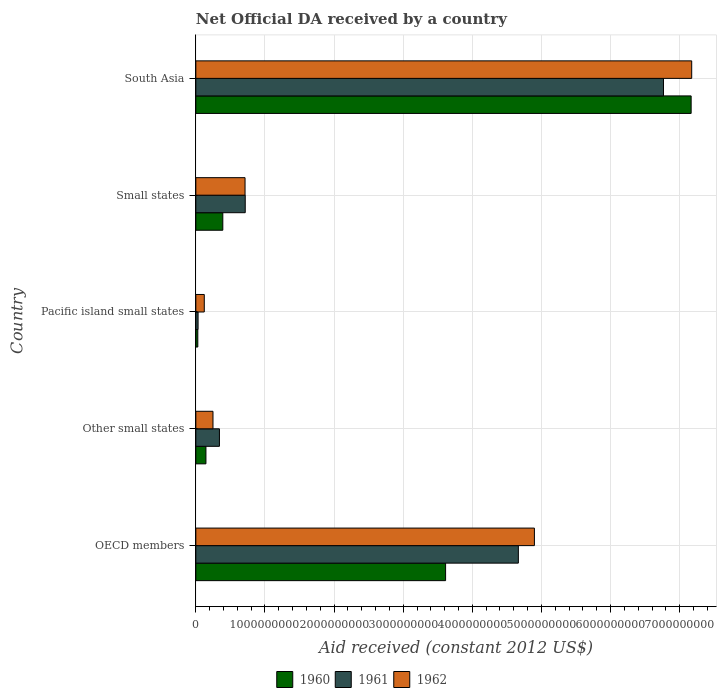How many different coloured bars are there?
Offer a terse response. 3. Are the number of bars per tick equal to the number of legend labels?
Offer a terse response. Yes. Are the number of bars on each tick of the Y-axis equal?
Offer a very short reply. Yes. How many bars are there on the 5th tick from the bottom?
Provide a short and direct response. 3. What is the label of the 5th group of bars from the top?
Make the answer very short. OECD members. In how many cases, is the number of bars for a given country not equal to the number of legend labels?
Offer a very short reply. 0. What is the net official development assistance aid received in 1962 in Pacific island small states?
Your response must be concise. 1.22e+08. Across all countries, what is the maximum net official development assistance aid received in 1961?
Give a very brief answer. 6.76e+09. Across all countries, what is the minimum net official development assistance aid received in 1962?
Provide a succinct answer. 1.22e+08. In which country was the net official development assistance aid received in 1961 minimum?
Offer a very short reply. Pacific island small states. What is the total net official development assistance aid received in 1960 in the graph?
Your answer should be compact. 1.13e+1. What is the difference between the net official development assistance aid received in 1961 in OECD members and that in Pacific island small states?
Ensure brevity in your answer.  4.63e+09. What is the difference between the net official development assistance aid received in 1960 in Other small states and the net official development assistance aid received in 1962 in Small states?
Your answer should be compact. -5.66e+08. What is the average net official development assistance aid received in 1960 per country?
Provide a succinct answer. 2.27e+09. What is the difference between the net official development assistance aid received in 1961 and net official development assistance aid received in 1960 in OECD members?
Make the answer very short. 1.05e+09. In how many countries, is the net official development assistance aid received in 1961 greater than 7200000000 US$?
Your answer should be very brief. 0. What is the ratio of the net official development assistance aid received in 1961 in Pacific island small states to that in South Asia?
Your answer should be compact. 0. Is the net official development assistance aid received in 1961 in Pacific island small states less than that in Small states?
Offer a terse response. Yes. Is the difference between the net official development assistance aid received in 1961 in Pacific island small states and South Asia greater than the difference between the net official development assistance aid received in 1960 in Pacific island small states and South Asia?
Offer a terse response. Yes. What is the difference between the highest and the second highest net official development assistance aid received in 1960?
Give a very brief answer. 3.55e+09. What is the difference between the highest and the lowest net official development assistance aid received in 1960?
Your answer should be very brief. 7.14e+09. In how many countries, is the net official development assistance aid received in 1961 greater than the average net official development assistance aid received in 1961 taken over all countries?
Provide a succinct answer. 2. What does the 2nd bar from the bottom in Other small states represents?
Your response must be concise. 1961. Is it the case that in every country, the sum of the net official development assistance aid received in 1961 and net official development assistance aid received in 1960 is greater than the net official development assistance aid received in 1962?
Provide a succinct answer. No. How many bars are there?
Provide a succinct answer. 15. How many countries are there in the graph?
Make the answer very short. 5. What is the difference between two consecutive major ticks on the X-axis?
Your response must be concise. 1.00e+09. Does the graph contain any zero values?
Keep it short and to the point. No. Where does the legend appear in the graph?
Your answer should be compact. Bottom center. How are the legend labels stacked?
Make the answer very short. Horizontal. What is the title of the graph?
Your answer should be very brief. Net Official DA received by a country. What is the label or title of the X-axis?
Provide a succinct answer. Aid received (constant 2012 US$). What is the label or title of the Y-axis?
Ensure brevity in your answer.  Country. What is the Aid received (constant 2012 US$) of 1960 in OECD members?
Offer a very short reply. 3.61e+09. What is the Aid received (constant 2012 US$) of 1961 in OECD members?
Provide a short and direct response. 4.67e+09. What is the Aid received (constant 2012 US$) of 1962 in OECD members?
Provide a succinct answer. 4.90e+09. What is the Aid received (constant 2012 US$) of 1960 in Other small states?
Your answer should be compact. 1.46e+08. What is the Aid received (constant 2012 US$) in 1961 in Other small states?
Your response must be concise. 3.41e+08. What is the Aid received (constant 2012 US$) in 1962 in Other small states?
Provide a short and direct response. 2.48e+08. What is the Aid received (constant 2012 US$) in 1960 in Pacific island small states?
Your answer should be compact. 2.87e+07. What is the Aid received (constant 2012 US$) of 1961 in Pacific island small states?
Provide a succinct answer. 3.25e+07. What is the Aid received (constant 2012 US$) in 1962 in Pacific island small states?
Your response must be concise. 1.22e+08. What is the Aid received (constant 2012 US$) of 1960 in Small states?
Your answer should be compact. 3.90e+08. What is the Aid received (constant 2012 US$) of 1961 in Small states?
Your response must be concise. 7.15e+08. What is the Aid received (constant 2012 US$) of 1962 in Small states?
Your answer should be compact. 7.12e+08. What is the Aid received (constant 2012 US$) of 1960 in South Asia?
Offer a terse response. 7.17e+09. What is the Aid received (constant 2012 US$) of 1961 in South Asia?
Make the answer very short. 6.76e+09. What is the Aid received (constant 2012 US$) of 1962 in South Asia?
Ensure brevity in your answer.  7.17e+09. Across all countries, what is the maximum Aid received (constant 2012 US$) of 1960?
Provide a succinct answer. 7.17e+09. Across all countries, what is the maximum Aid received (constant 2012 US$) in 1961?
Offer a terse response. 6.76e+09. Across all countries, what is the maximum Aid received (constant 2012 US$) of 1962?
Give a very brief answer. 7.17e+09. Across all countries, what is the minimum Aid received (constant 2012 US$) of 1960?
Offer a very short reply. 2.87e+07. Across all countries, what is the minimum Aid received (constant 2012 US$) in 1961?
Provide a short and direct response. 3.25e+07. Across all countries, what is the minimum Aid received (constant 2012 US$) in 1962?
Your answer should be very brief. 1.22e+08. What is the total Aid received (constant 2012 US$) of 1960 in the graph?
Your answer should be very brief. 1.13e+1. What is the total Aid received (constant 2012 US$) in 1961 in the graph?
Give a very brief answer. 1.25e+1. What is the total Aid received (constant 2012 US$) in 1962 in the graph?
Give a very brief answer. 1.32e+1. What is the difference between the Aid received (constant 2012 US$) in 1960 in OECD members and that in Other small states?
Make the answer very short. 3.47e+09. What is the difference between the Aid received (constant 2012 US$) of 1961 in OECD members and that in Other small states?
Your response must be concise. 4.32e+09. What is the difference between the Aid received (constant 2012 US$) of 1962 in OECD members and that in Other small states?
Your answer should be compact. 4.65e+09. What is the difference between the Aid received (constant 2012 US$) of 1960 in OECD members and that in Pacific island small states?
Make the answer very short. 3.58e+09. What is the difference between the Aid received (constant 2012 US$) in 1961 in OECD members and that in Pacific island small states?
Your answer should be compact. 4.63e+09. What is the difference between the Aid received (constant 2012 US$) of 1962 in OECD members and that in Pacific island small states?
Give a very brief answer. 4.78e+09. What is the difference between the Aid received (constant 2012 US$) of 1960 in OECD members and that in Small states?
Your response must be concise. 3.22e+09. What is the difference between the Aid received (constant 2012 US$) in 1961 in OECD members and that in Small states?
Provide a short and direct response. 3.95e+09. What is the difference between the Aid received (constant 2012 US$) of 1962 in OECD members and that in Small states?
Provide a short and direct response. 4.19e+09. What is the difference between the Aid received (constant 2012 US$) in 1960 in OECD members and that in South Asia?
Provide a short and direct response. -3.55e+09. What is the difference between the Aid received (constant 2012 US$) of 1961 in OECD members and that in South Asia?
Ensure brevity in your answer.  -2.10e+09. What is the difference between the Aid received (constant 2012 US$) of 1962 in OECD members and that in South Asia?
Ensure brevity in your answer.  -2.28e+09. What is the difference between the Aid received (constant 2012 US$) in 1960 in Other small states and that in Pacific island small states?
Provide a succinct answer. 1.17e+08. What is the difference between the Aid received (constant 2012 US$) in 1961 in Other small states and that in Pacific island small states?
Ensure brevity in your answer.  3.09e+08. What is the difference between the Aid received (constant 2012 US$) in 1962 in Other small states and that in Pacific island small states?
Offer a very short reply. 1.26e+08. What is the difference between the Aid received (constant 2012 US$) of 1960 in Other small states and that in Small states?
Provide a succinct answer. -2.44e+08. What is the difference between the Aid received (constant 2012 US$) in 1961 in Other small states and that in Small states?
Offer a terse response. -3.73e+08. What is the difference between the Aid received (constant 2012 US$) in 1962 in Other small states and that in Small states?
Your answer should be very brief. -4.64e+08. What is the difference between the Aid received (constant 2012 US$) of 1960 in Other small states and that in South Asia?
Make the answer very short. -7.02e+09. What is the difference between the Aid received (constant 2012 US$) of 1961 in Other small states and that in South Asia?
Offer a very short reply. -6.42e+09. What is the difference between the Aid received (constant 2012 US$) of 1962 in Other small states and that in South Asia?
Offer a terse response. -6.93e+09. What is the difference between the Aid received (constant 2012 US$) in 1960 in Pacific island small states and that in Small states?
Your answer should be compact. -3.62e+08. What is the difference between the Aid received (constant 2012 US$) of 1961 in Pacific island small states and that in Small states?
Ensure brevity in your answer.  -6.82e+08. What is the difference between the Aid received (constant 2012 US$) in 1962 in Pacific island small states and that in Small states?
Provide a succinct answer. -5.90e+08. What is the difference between the Aid received (constant 2012 US$) in 1960 in Pacific island small states and that in South Asia?
Provide a short and direct response. -7.14e+09. What is the difference between the Aid received (constant 2012 US$) of 1961 in Pacific island small states and that in South Asia?
Give a very brief answer. -6.73e+09. What is the difference between the Aid received (constant 2012 US$) of 1962 in Pacific island small states and that in South Asia?
Your answer should be compact. -7.05e+09. What is the difference between the Aid received (constant 2012 US$) in 1960 in Small states and that in South Asia?
Provide a succinct answer. -6.77e+09. What is the difference between the Aid received (constant 2012 US$) of 1961 in Small states and that in South Asia?
Offer a terse response. -6.05e+09. What is the difference between the Aid received (constant 2012 US$) of 1962 in Small states and that in South Asia?
Your response must be concise. -6.46e+09. What is the difference between the Aid received (constant 2012 US$) in 1960 in OECD members and the Aid received (constant 2012 US$) in 1961 in Other small states?
Ensure brevity in your answer.  3.27e+09. What is the difference between the Aid received (constant 2012 US$) of 1960 in OECD members and the Aid received (constant 2012 US$) of 1962 in Other small states?
Provide a short and direct response. 3.36e+09. What is the difference between the Aid received (constant 2012 US$) in 1961 in OECD members and the Aid received (constant 2012 US$) in 1962 in Other small states?
Ensure brevity in your answer.  4.42e+09. What is the difference between the Aid received (constant 2012 US$) of 1960 in OECD members and the Aid received (constant 2012 US$) of 1961 in Pacific island small states?
Offer a very short reply. 3.58e+09. What is the difference between the Aid received (constant 2012 US$) in 1960 in OECD members and the Aid received (constant 2012 US$) in 1962 in Pacific island small states?
Make the answer very short. 3.49e+09. What is the difference between the Aid received (constant 2012 US$) in 1961 in OECD members and the Aid received (constant 2012 US$) in 1962 in Pacific island small states?
Provide a succinct answer. 4.54e+09. What is the difference between the Aid received (constant 2012 US$) of 1960 in OECD members and the Aid received (constant 2012 US$) of 1961 in Small states?
Your answer should be compact. 2.90e+09. What is the difference between the Aid received (constant 2012 US$) of 1960 in OECD members and the Aid received (constant 2012 US$) of 1962 in Small states?
Offer a terse response. 2.90e+09. What is the difference between the Aid received (constant 2012 US$) in 1961 in OECD members and the Aid received (constant 2012 US$) in 1962 in Small states?
Give a very brief answer. 3.95e+09. What is the difference between the Aid received (constant 2012 US$) of 1960 in OECD members and the Aid received (constant 2012 US$) of 1961 in South Asia?
Offer a very short reply. -3.15e+09. What is the difference between the Aid received (constant 2012 US$) of 1960 in OECD members and the Aid received (constant 2012 US$) of 1962 in South Asia?
Offer a terse response. -3.56e+09. What is the difference between the Aid received (constant 2012 US$) of 1961 in OECD members and the Aid received (constant 2012 US$) of 1962 in South Asia?
Keep it short and to the point. -2.51e+09. What is the difference between the Aid received (constant 2012 US$) in 1960 in Other small states and the Aid received (constant 2012 US$) in 1961 in Pacific island small states?
Your response must be concise. 1.14e+08. What is the difference between the Aid received (constant 2012 US$) in 1960 in Other small states and the Aid received (constant 2012 US$) in 1962 in Pacific island small states?
Your answer should be very brief. 2.39e+07. What is the difference between the Aid received (constant 2012 US$) in 1961 in Other small states and the Aid received (constant 2012 US$) in 1962 in Pacific island small states?
Offer a terse response. 2.19e+08. What is the difference between the Aid received (constant 2012 US$) in 1960 in Other small states and the Aid received (constant 2012 US$) in 1961 in Small states?
Offer a terse response. -5.69e+08. What is the difference between the Aid received (constant 2012 US$) of 1960 in Other small states and the Aid received (constant 2012 US$) of 1962 in Small states?
Keep it short and to the point. -5.66e+08. What is the difference between the Aid received (constant 2012 US$) of 1961 in Other small states and the Aid received (constant 2012 US$) of 1962 in Small states?
Your answer should be very brief. -3.71e+08. What is the difference between the Aid received (constant 2012 US$) of 1960 in Other small states and the Aid received (constant 2012 US$) of 1961 in South Asia?
Make the answer very short. -6.62e+09. What is the difference between the Aid received (constant 2012 US$) of 1960 in Other small states and the Aid received (constant 2012 US$) of 1962 in South Asia?
Your response must be concise. -7.03e+09. What is the difference between the Aid received (constant 2012 US$) in 1961 in Other small states and the Aid received (constant 2012 US$) in 1962 in South Asia?
Offer a very short reply. -6.83e+09. What is the difference between the Aid received (constant 2012 US$) in 1960 in Pacific island small states and the Aid received (constant 2012 US$) in 1961 in Small states?
Your answer should be compact. -6.86e+08. What is the difference between the Aid received (constant 2012 US$) in 1960 in Pacific island small states and the Aid received (constant 2012 US$) in 1962 in Small states?
Your response must be concise. -6.83e+08. What is the difference between the Aid received (constant 2012 US$) of 1961 in Pacific island small states and the Aid received (constant 2012 US$) of 1962 in Small states?
Your response must be concise. -6.80e+08. What is the difference between the Aid received (constant 2012 US$) of 1960 in Pacific island small states and the Aid received (constant 2012 US$) of 1961 in South Asia?
Your answer should be compact. -6.74e+09. What is the difference between the Aid received (constant 2012 US$) in 1960 in Pacific island small states and the Aid received (constant 2012 US$) in 1962 in South Asia?
Your answer should be very brief. -7.14e+09. What is the difference between the Aid received (constant 2012 US$) of 1961 in Pacific island small states and the Aid received (constant 2012 US$) of 1962 in South Asia?
Give a very brief answer. -7.14e+09. What is the difference between the Aid received (constant 2012 US$) in 1960 in Small states and the Aid received (constant 2012 US$) in 1961 in South Asia?
Your answer should be very brief. -6.37e+09. What is the difference between the Aid received (constant 2012 US$) in 1960 in Small states and the Aid received (constant 2012 US$) in 1962 in South Asia?
Make the answer very short. -6.78e+09. What is the difference between the Aid received (constant 2012 US$) in 1961 in Small states and the Aid received (constant 2012 US$) in 1962 in South Asia?
Provide a short and direct response. -6.46e+09. What is the average Aid received (constant 2012 US$) of 1960 per country?
Offer a terse response. 2.27e+09. What is the average Aid received (constant 2012 US$) in 1961 per country?
Provide a succinct answer. 2.50e+09. What is the average Aid received (constant 2012 US$) in 1962 per country?
Provide a short and direct response. 2.63e+09. What is the difference between the Aid received (constant 2012 US$) in 1960 and Aid received (constant 2012 US$) in 1961 in OECD members?
Give a very brief answer. -1.05e+09. What is the difference between the Aid received (constant 2012 US$) in 1960 and Aid received (constant 2012 US$) in 1962 in OECD members?
Ensure brevity in your answer.  -1.28e+09. What is the difference between the Aid received (constant 2012 US$) of 1961 and Aid received (constant 2012 US$) of 1962 in OECD members?
Ensure brevity in your answer.  -2.32e+08. What is the difference between the Aid received (constant 2012 US$) of 1960 and Aid received (constant 2012 US$) of 1961 in Other small states?
Give a very brief answer. -1.95e+08. What is the difference between the Aid received (constant 2012 US$) of 1960 and Aid received (constant 2012 US$) of 1962 in Other small states?
Your answer should be very brief. -1.02e+08. What is the difference between the Aid received (constant 2012 US$) of 1961 and Aid received (constant 2012 US$) of 1962 in Other small states?
Your answer should be very brief. 9.32e+07. What is the difference between the Aid received (constant 2012 US$) in 1960 and Aid received (constant 2012 US$) in 1961 in Pacific island small states?
Offer a terse response. -3.76e+06. What is the difference between the Aid received (constant 2012 US$) of 1960 and Aid received (constant 2012 US$) of 1962 in Pacific island small states?
Give a very brief answer. -9.36e+07. What is the difference between the Aid received (constant 2012 US$) of 1961 and Aid received (constant 2012 US$) of 1962 in Pacific island small states?
Keep it short and to the point. -8.98e+07. What is the difference between the Aid received (constant 2012 US$) of 1960 and Aid received (constant 2012 US$) of 1961 in Small states?
Keep it short and to the point. -3.24e+08. What is the difference between the Aid received (constant 2012 US$) in 1960 and Aid received (constant 2012 US$) in 1962 in Small states?
Your answer should be very brief. -3.22e+08. What is the difference between the Aid received (constant 2012 US$) in 1961 and Aid received (constant 2012 US$) in 1962 in Small states?
Offer a very short reply. 2.71e+06. What is the difference between the Aid received (constant 2012 US$) of 1960 and Aid received (constant 2012 US$) of 1961 in South Asia?
Ensure brevity in your answer.  4.00e+08. What is the difference between the Aid received (constant 2012 US$) of 1960 and Aid received (constant 2012 US$) of 1962 in South Asia?
Ensure brevity in your answer.  -8.03e+06. What is the difference between the Aid received (constant 2012 US$) of 1961 and Aid received (constant 2012 US$) of 1962 in South Asia?
Ensure brevity in your answer.  -4.08e+08. What is the ratio of the Aid received (constant 2012 US$) in 1960 in OECD members to that in Other small states?
Provide a short and direct response. 24.72. What is the ratio of the Aid received (constant 2012 US$) of 1961 in OECD members to that in Other small states?
Provide a short and direct response. 13.66. What is the ratio of the Aid received (constant 2012 US$) in 1962 in OECD members to that in Other small states?
Your answer should be compact. 19.73. What is the ratio of the Aid received (constant 2012 US$) of 1960 in OECD members to that in Pacific island small states?
Your answer should be compact. 125.84. What is the ratio of the Aid received (constant 2012 US$) in 1961 in OECD members to that in Pacific island small states?
Provide a succinct answer. 143.69. What is the ratio of the Aid received (constant 2012 US$) in 1962 in OECD members to that in Pacific island small states?
Offer a terse response. 40.06. What is the ratio of the Aid received (constant 2012 US$) in 1960 in OECD members to that in Small states?
Give a very brief answer. 9.26. What is the ratio of the Aid received (constant 2012 US$) of 1961 in OECD members to that in Small states?
Ensure brevity in your answer.  6.53. What is the ratio of the Aid received (constant 2012 US$) in 1962 in OECD members to that in Small states?
Offer a very short reply. 6.88. What is the ratio of the Aid received (constant 2012 US$) of 1960 in OECD members to that in South Asia?
Your answer should be compact. 0.5. What is the ratio of the Aid received (constant 2012 US$) of 1961 in OECD members to that in South Asia?
Your answer should be very brief. 0.69. What is the ratio of the Aid received (constant 2012 US$) in 1962 in OECD members to that in South Asia?
Offer a terse response. 0.68. What is the ratio of the Aid received (constant 2012 US$) in 1960 in Other small states to that in Pacific island small states?
Your answer should be very brief. 5.09. What is the ratio of the Aid received (constant 2012 US$) in 1961 in Other small states to that in Pacific island small states?
Your response must be concise. 10.52. What is the ratio of the Aid received (constant 2012 US$) in 1962 in Other small states to that in Pacific island small states?
Make the answer very short. 2.03. What is the ratio of the Aid received (constant 2012 US$) of 1960 in Other small states to that in Small states?
Your answer should be compact. 0.37. What is the ratio of the Aid received (constant 2012 US$) of 1961 in Other small states to that in Small states?
Keep it short and to the point. 0.48. What is the ratio of the Aid received (constant 2012 US$) of 1962 in Other small states to that in Small states?
Give a very brief answer. 0.35. What is the ratio of the Aid received (constant 2012 US$) in 1960 in Other small states to that in South Asia?
Provide a short and direct response. 0.02. What is the ratio of the Aid received (constant 2012 US$) of 1961 in Other small states to that in South Asia?
Give a very brief answer. 0.05. What is the ratio of the Aid received (constant 2012 US$) in 1962 in Other small states to that in South Asia?
Provide a succinct answer. 0.03. What is the ratio of the Aid received (constant 2012 US$) in 1960 in Pacific island small states to that in Small states?
Offer a terse response. 0.07. What is the ratio of the Aid received (constant 2012 US$) of 1961 in Pacific island small states to that in Small states?
Offer a terse response. 0.05. What is the ratio of the Aid received (constant 2012 US$) in 1962 in Pacific island small states to that in Small states?
Provide a succinct answer. 0.17. What is the ratio of the Aid received (constant 2012 US$) in 1960 in Pacific island small states to that in South Asia?
Offer a very short reply. 0. What is the ratio of the Aid received (constant 2012 US$) of 1961 in Pacific island small states to that in South Asia?
Your answer should be very brief. 0. What is the ratio of the Aid received (constant 2012 US$) of 1962 in Pacific island small states to that in South Asia?
Ensure brevity in your answer.  0.02. What is the ratio of the Aid received (constant 2012 US$) of 1960 in Small states to that in South Asia?
Give a very brief answer. 0.05. What is the ratio of the Aid received (constant 2012 US$) in 1961 in Small states to that in South Asia?
Your response must be concise. 0.11. What is the ratio of the Aid received (constant 2012 US$) of 1962 in Small states to that in South Asia?
Ensure brevity in your answer.  0.1. What is the difference between the highest and the second highest Aid received (constant 2012 US$) of 1960?
Ensure brevity in your answer.  3.55e+09. What is the difference between the highest and the second highest Aid received (constant 2012 US$) of 1961?
Provide a short and direct response. 2.10e+09. What is the difference between the highest and the second highest Aid received (constant 2012 US$) of 1962?
Your response must be concise. 2.28e+09. What is the difference between the highest and the lowest Aid received (constant 2012 US$) in 1960?
Offer a terse response. 7.14e+09. What is the difference between the highest and the lowest Aid received (constant 2012 US$) in 1961?
Keep it short and to the point. 6.73e+09. What is the difference between the highest and the lowest Aid received (constant 2012 US$) of 1962?
Make the answer very short. 7.05e+09. 